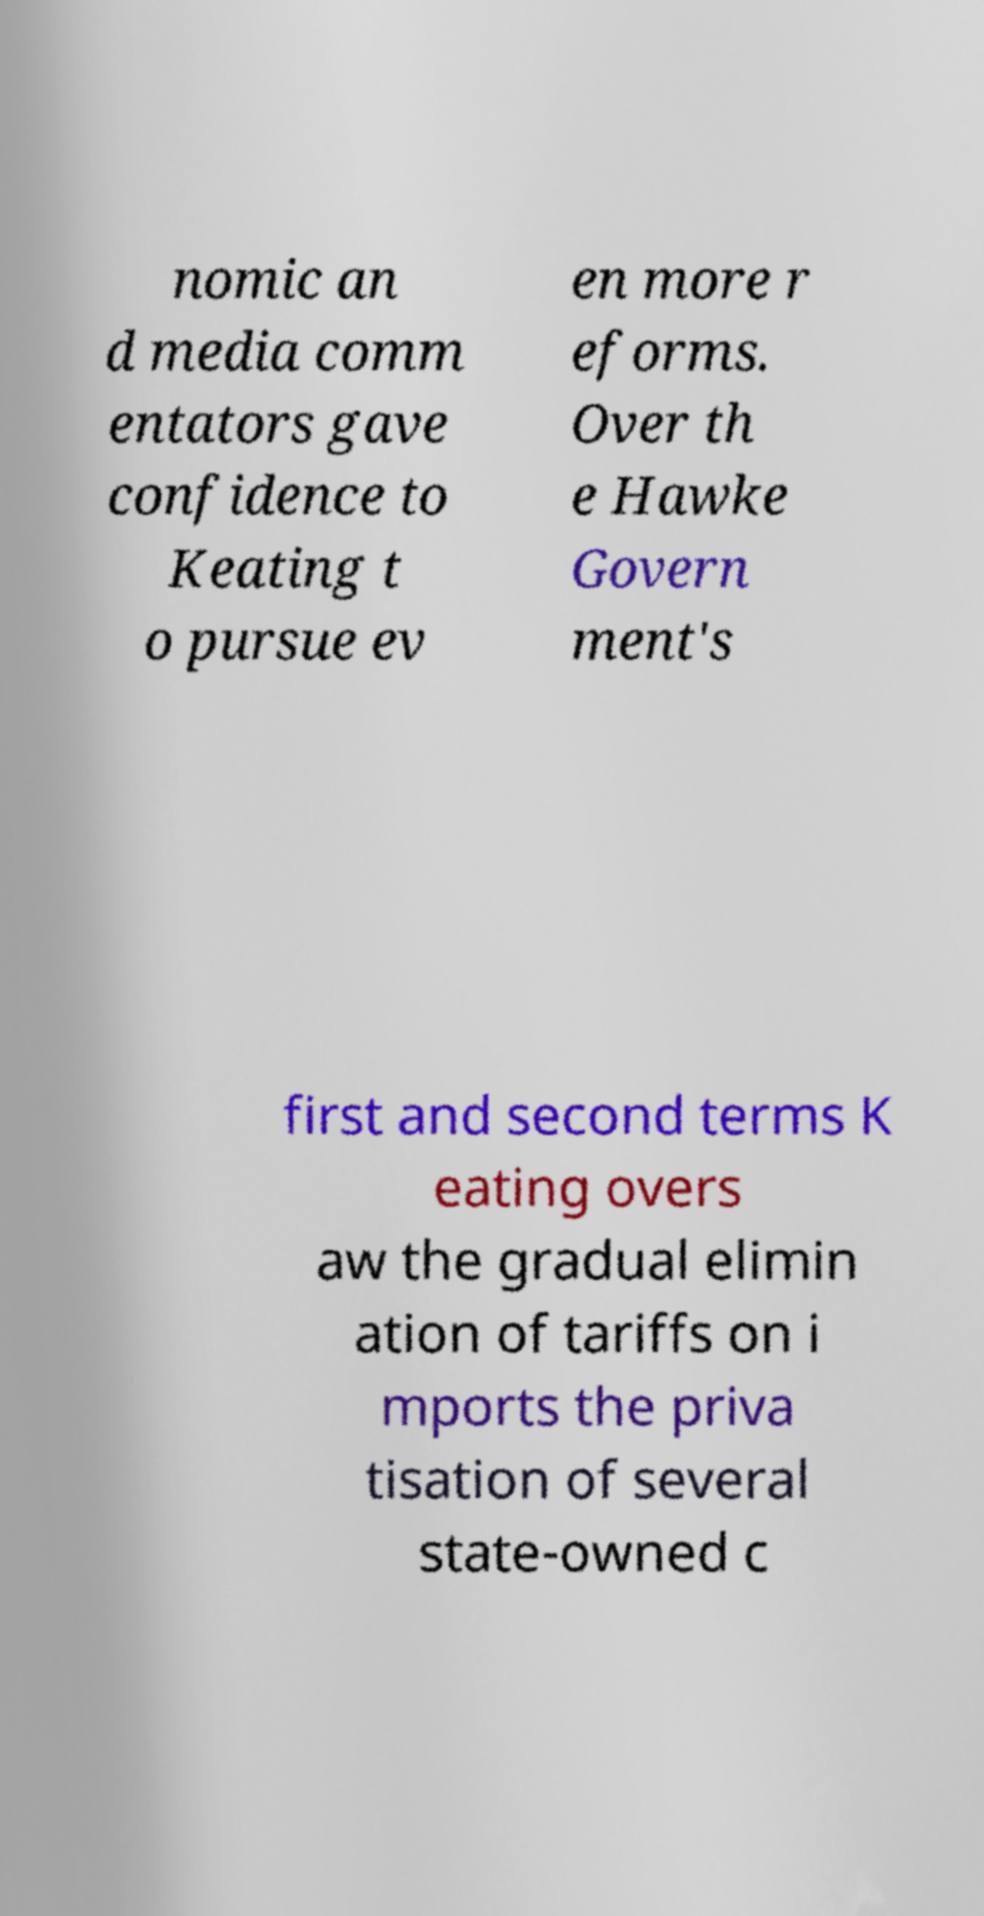Please read and relay the text visible in this image. What does it say? nomic an d media comm entators gave confidence to Keating t o pursue ev en more r eforms. Over th e Hawke Govern ment's first and second terms K eating overs aw the gradual elimin ation of tariffs on i mports the priva tisation of several state-owned c 